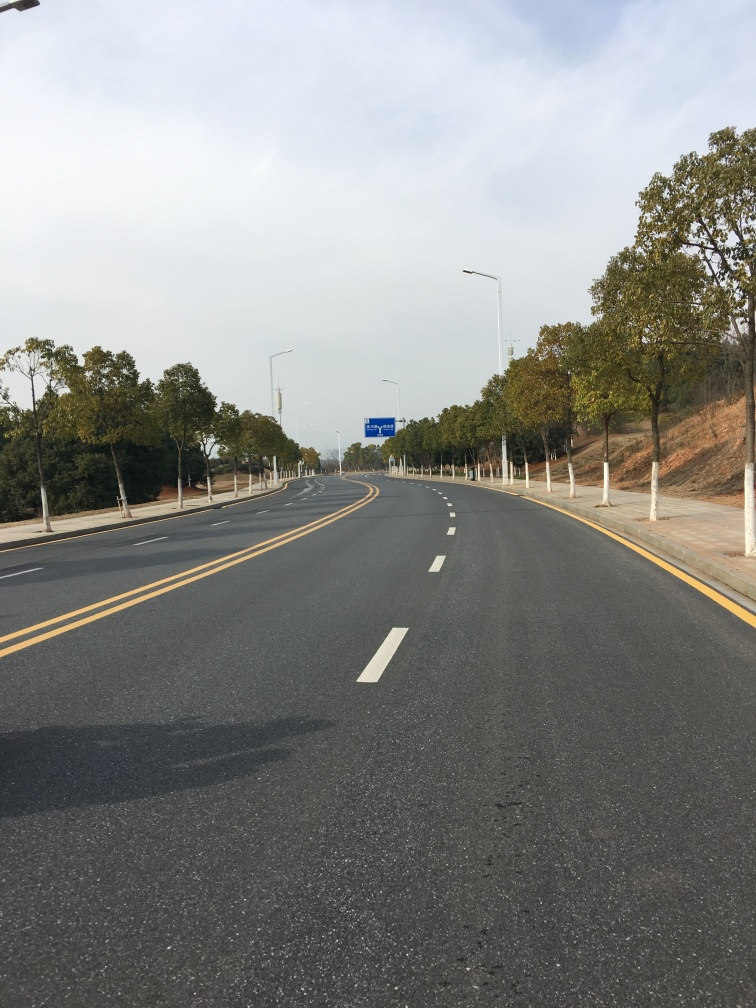What time of day does it appear to be in this image? It looks to be daytime, given the well-lit environment and the shadows that are visible on the road, suggesting that the sun is at a midday or early afternoon position. 